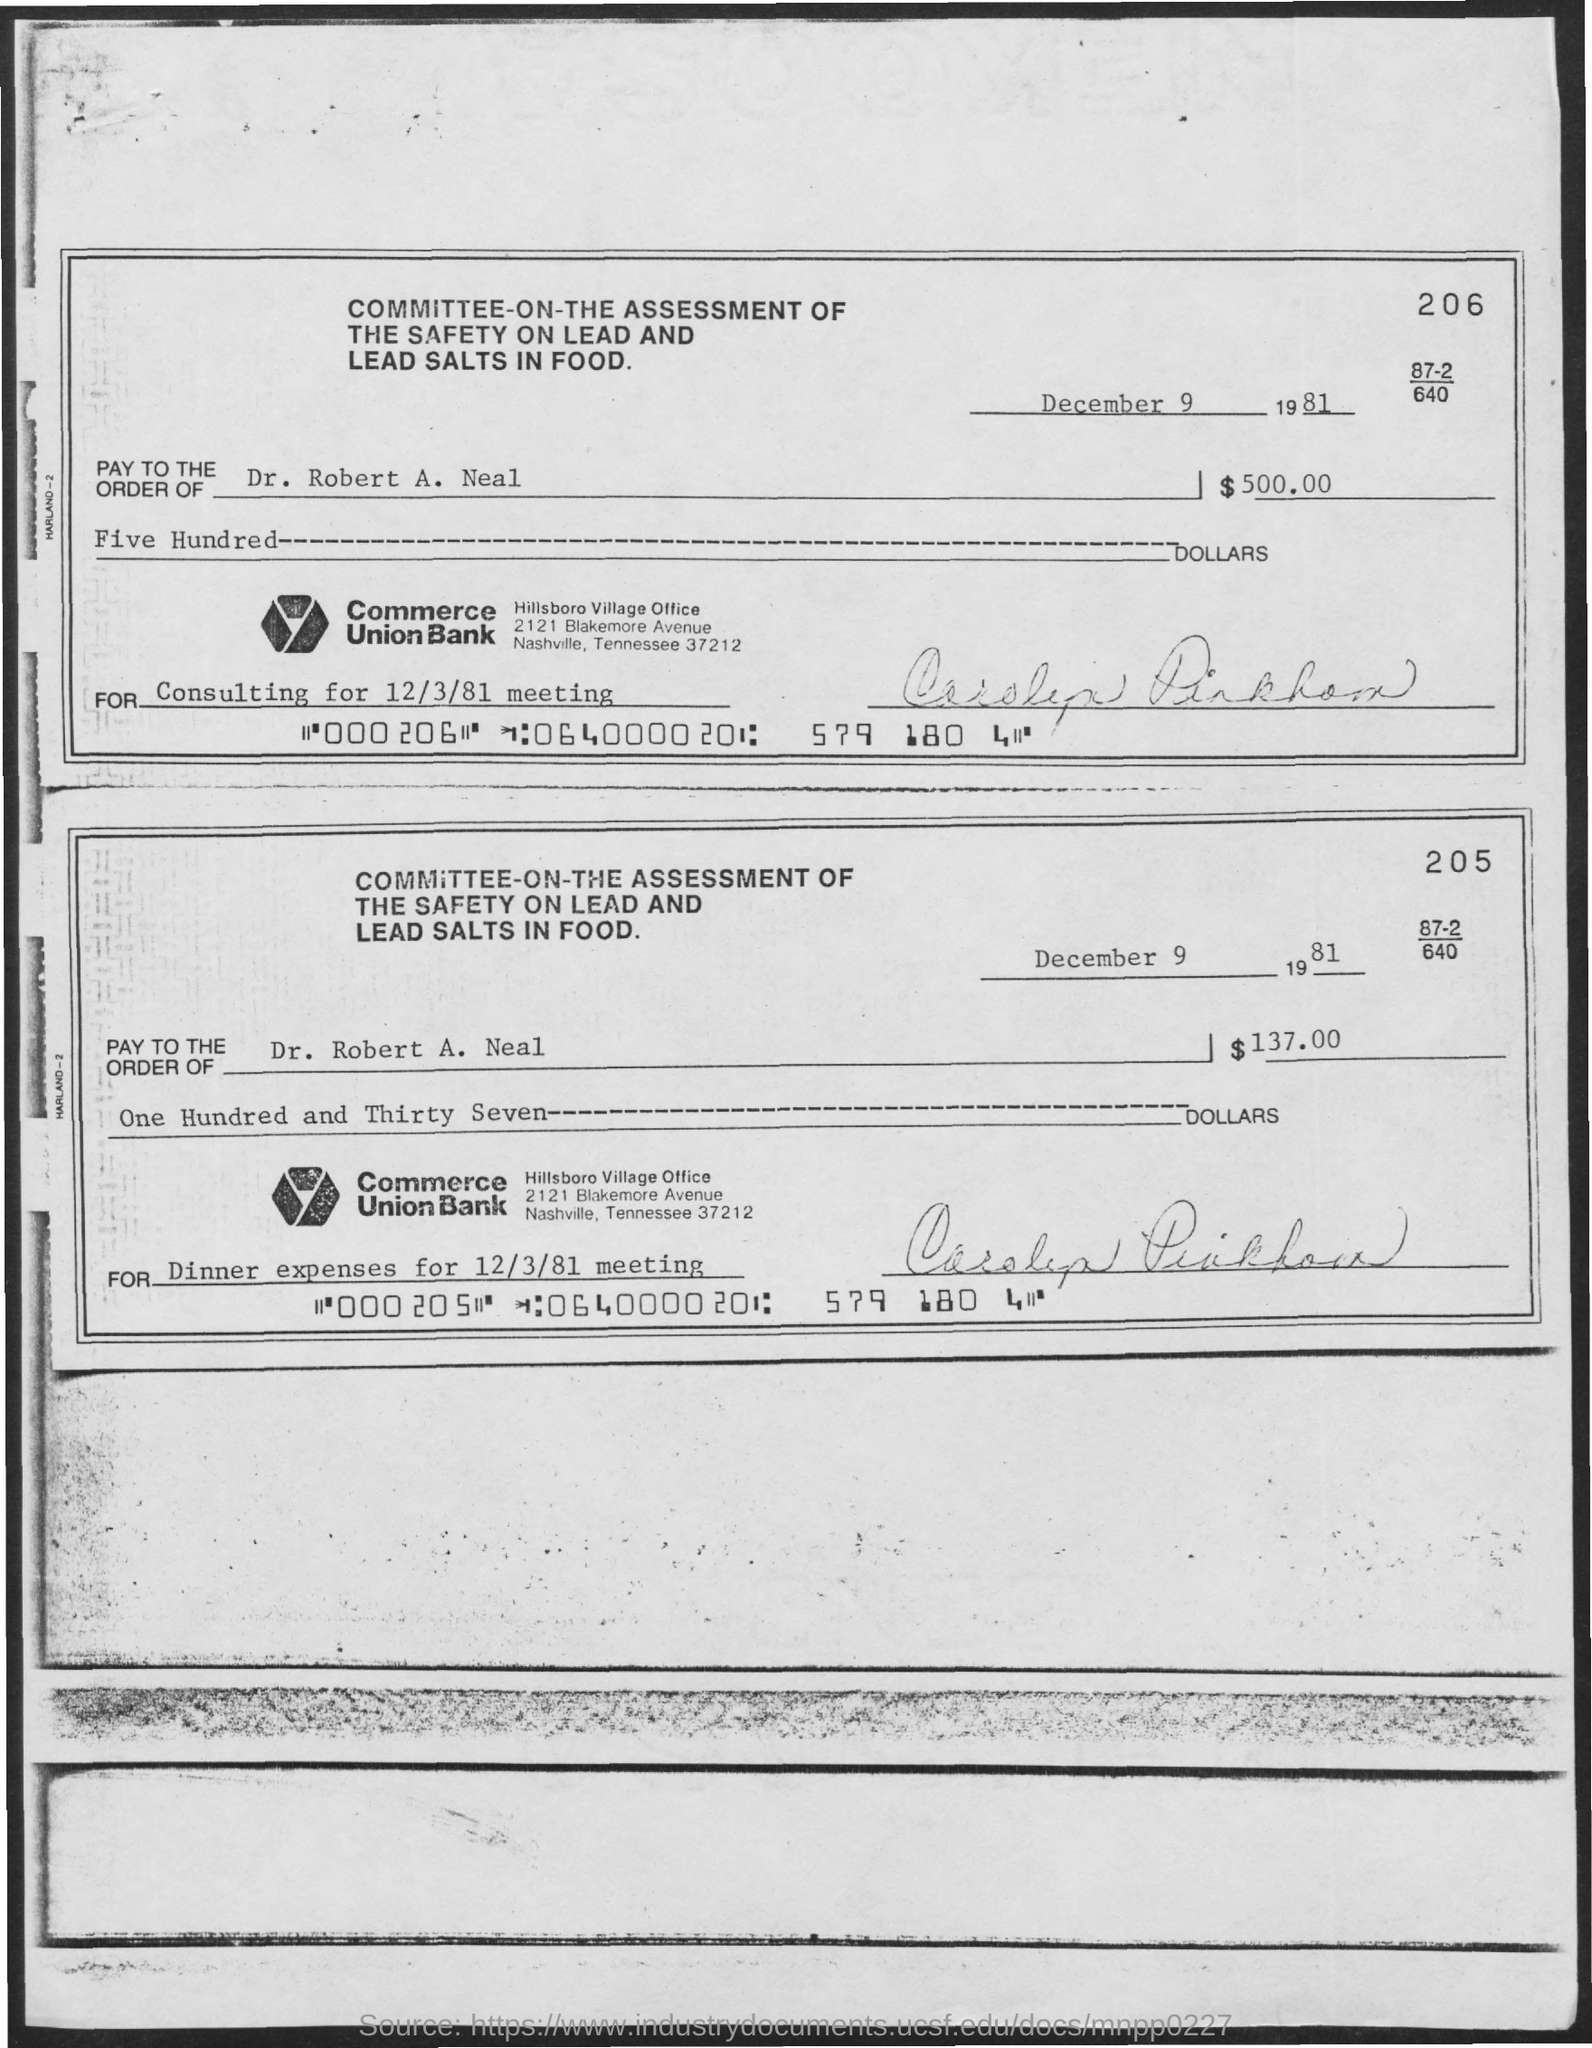Outline some significant characteristics in this image. The check should be paid to Dr. Robert A. Neal. The amount to be paid for consulting is $500.00 in dollars. The document is dated December 9, 1981. The purpose of check 205 is to cover the dinner expenses for the 12/3/81 meeting. 